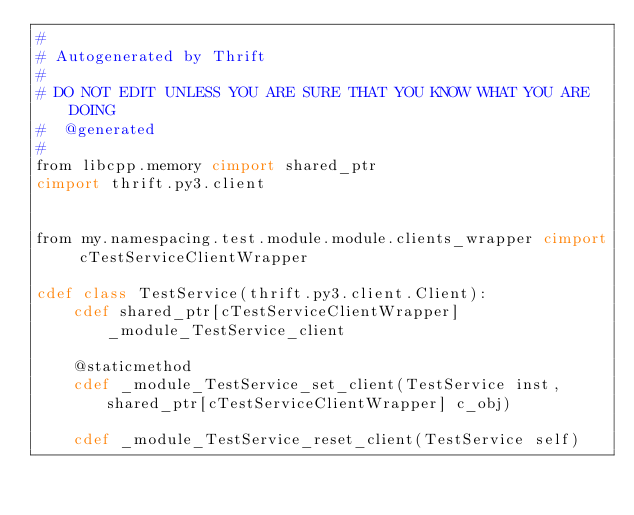Convert code to text. <code><loc_0><loc_0><loc_500><loc_500><_Cython_>#
# Autogenerated by Thrift
#
# DO NOT EDIT UNLESS YOU ARE SURE THAT YOU KNOW WHAT YOU ARE DOING
#  @generated
#
from libcpp.memory cimport shared_ptr
cimport thrift.py3.client


from my.namespacing.test.module.module.clients_wrapper cimport cTestServiceClientWrapper

cdef class TestService(thrift.py3.client.Client):
    cdef shared_ptr[cTestServiceClientWrapper] _module_TestService_client

    @staticmethod
    cdef _module_TestService_set_client(TestService inst, shared_ptr[cTestServiceClientWrapper] c_obj)

    cdef _module_TestService_reset_client(TestService self)

</code> 